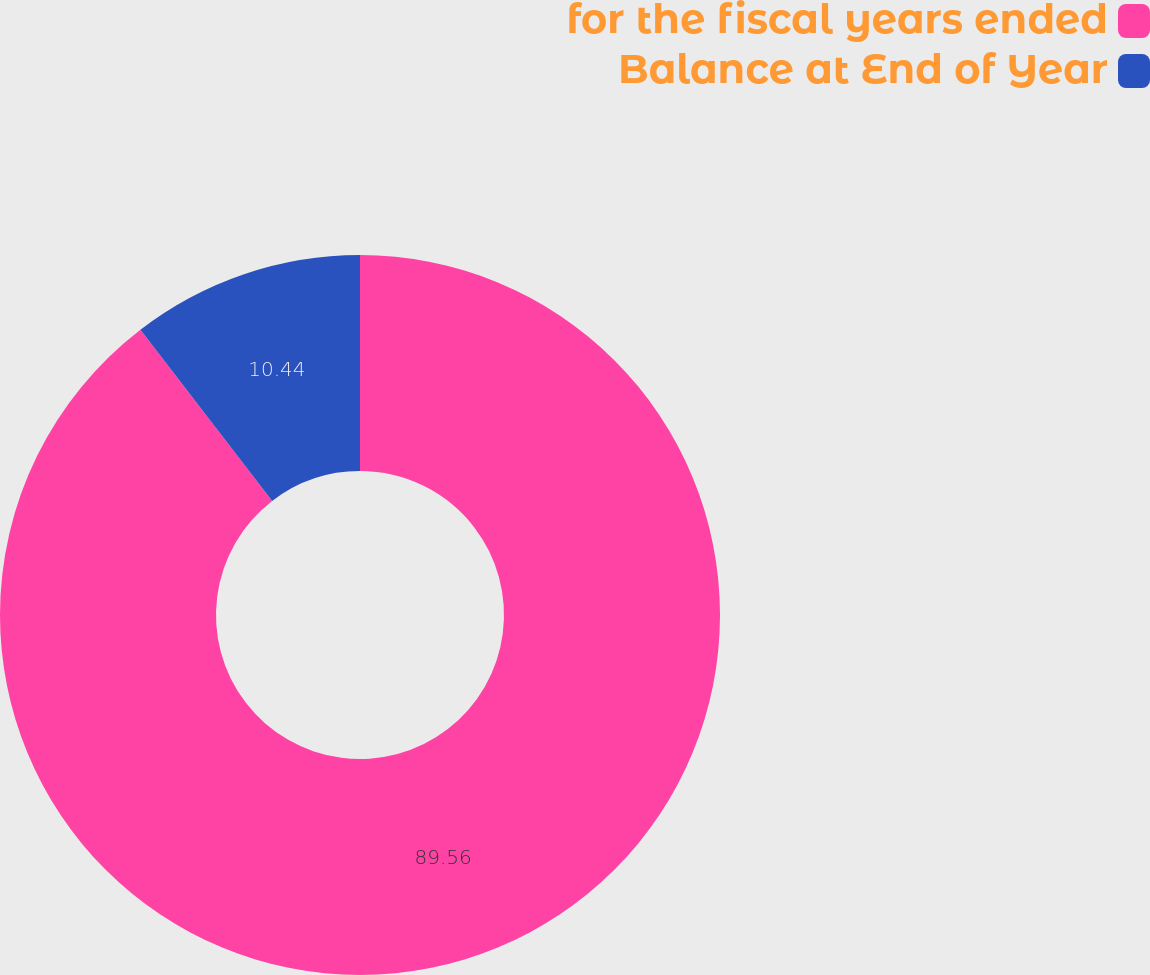Convert chart. <chart><loc_0><loc_0><loc_500><loc_500><pie_chart><fcel>for the fiscal years ended<fcel>Balance at End of Year<nl><fcel>89.56%<fcel>10.44%<nl></chart> 